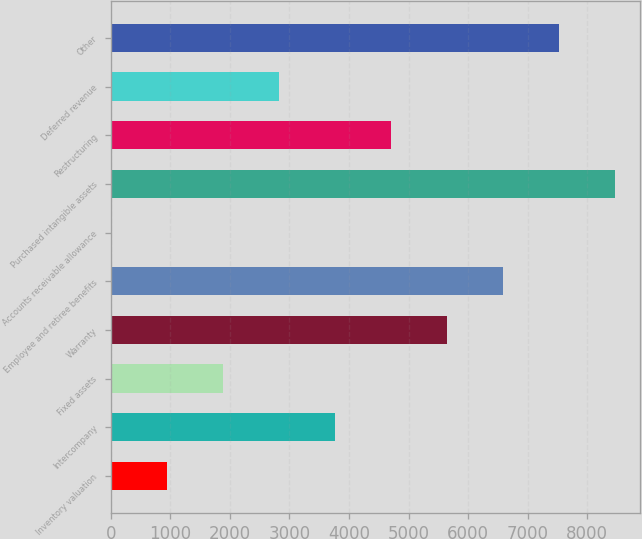<chart> <loc_0><loc_0><loc_500><loc_500><bar_chart><fcel>Inventory valuation<fcel>Intercompany<fcel>Fixed assets<fcel>Warranty<fcel>Employee and retiree benefits<fcel>Accounts receivable allowance<fcel>Purchased intangible assets<fcel>Restructuring<fcel>Deferred revenue<fcel>Other<nl><fcel>944.9<fcel>3767.6<fcel>1885.8<fcel>5649.4<fcel>6590.3<fcel>4<fcel>8472.1<fcel>4708.5<fcel>2826.7<fcel>7531.2<nl></chart> 